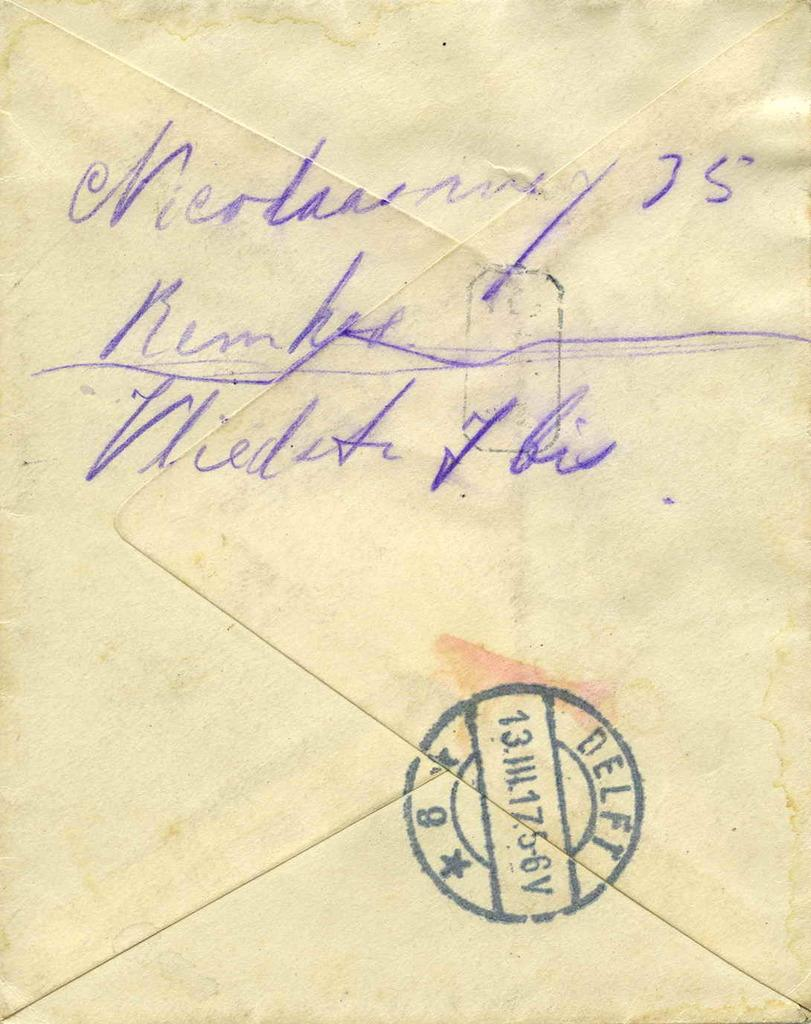<image>
Write a terse but informative summary of the picture. A really old envelope with hand writing on the back. 